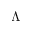<formula> <loc_0><loc_0><loc_500><loc_500>\Lambda</formula> 